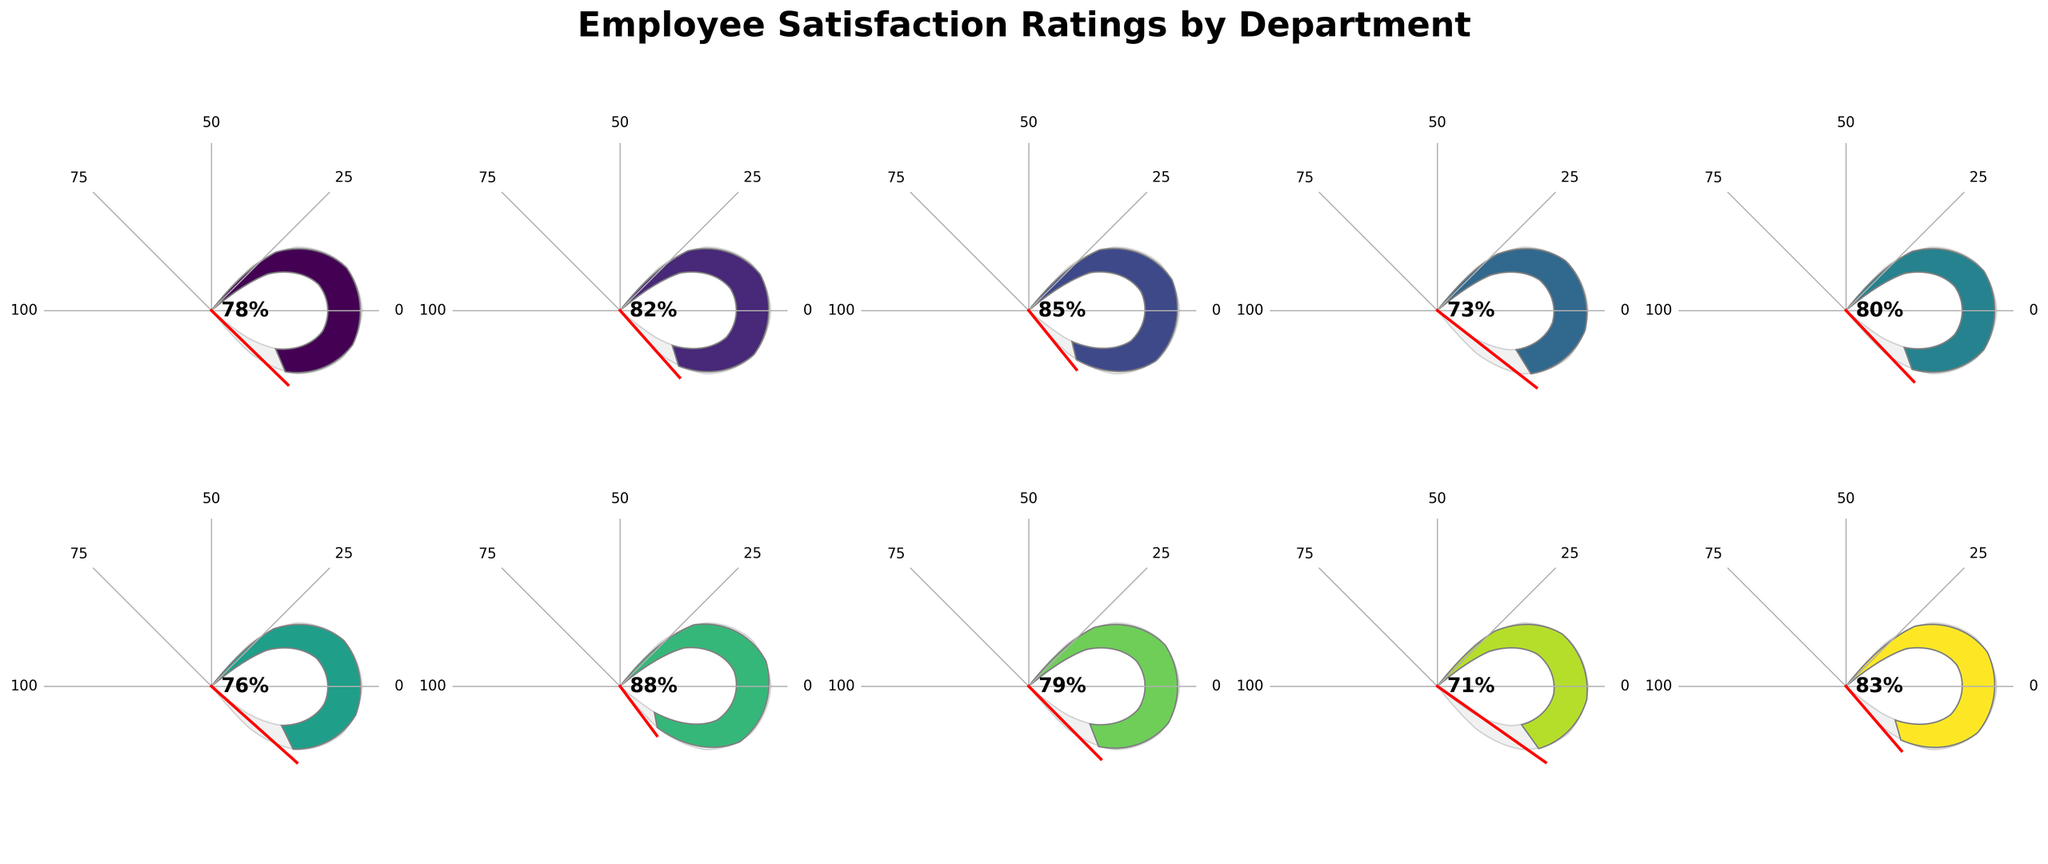Which department has the highest employee satisfaction rating? The department with the highest satisfaction rating is the one whose gauge reaches the farthest on the scale. Research & Development shows the highest value at 88%.
Answer: Research & Development Which department has the lowest employee satisfaction rating? The department with the lowest satisfaction rating is the one with the shortest gauge on the scale. Legal has the lowest rating at 71%.
Answer: Legal What's the average satisfaction rating across all departments? Add up all the satisfaction ratings and divide by the number of departments: (78 + 82 + 85 + 73 + 80 + 76 + 88 + 79 + 71 + 83) / 10 = 79.5.
Answer: 79.5 Identify all departments with satisfaction ratings above 80%. The departments with gauges extending beyond the 80% mark are identified: Marketing, Sales, Research & Development, and Product Management.
Answer: Marketing, Sales, Research & Development, Product Management Compare the satisfaction ratings of IT and Customer Service. Which one is higher? The satisfaction rating of IT is 80%, while Customer Service is 76%. Hence, IT has a higher satisfaction rating.
Answer: IT How many departments have a satisfaction rating between 70% and 80%? Count the departments whose gauges fall within the 70-80% range: Human Resources (78), Finance (73), Customer Service (76), Operations (79), Legal (71) - total of 5 departments.
Answer: 5 What’s the difference in satisfaction ratings between Sales and Finance? The satisfaction ratings are 85% for Sales and 73% for Finance. The difference is 85 - 73 = 12%.
Answer: 12% Which department is closest to the median satisfaction rating observed in the chart? The sorted ratings are: 71, 73, 76, 78, 79, 80, 82, 83, 85, 88. With 10 departments, the median is the average of the 5th and 6th values: (79 + 80) / 2 = 79.5. Operations and IT are closest to this median value.
Answer: Operations and IT What is the range of the employee satisfaction ratings? Identify the highest (88%) and lowest (71%) ratings, then compute their difference: 88 - 71 = 17%.
Answer: 17% Which departments have satisfaction ratings within 5% of each other? Analyzing the satisfaction ratings: Human Resources (78), Marketing (82), IT (80), Customer Service (76), Operations (79). Close groups include Human Resources, IT, and Operations (within 2%); and Marketing with Product Management (within 1%).
Answer: Human Resources, IT, Operations; Marketing, Product Management 